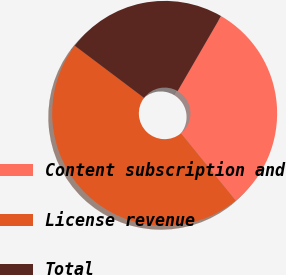Convert chart. <chart><loc_0><loc_0><loc_500><loc_500><pie_chart><fcel>Content subscription and<fcel>License revenue<fcel>Total<nl><fcel>30.77%<fcel>46.15%<fcel>23.08%<nl></chart> 